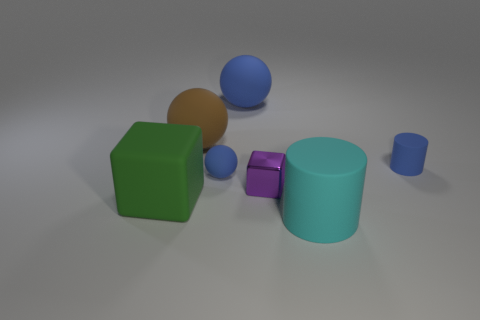Subtract all brown matte balls. How many balls are left? 2 Subtract all green blocks. How many blue balls are left? 2 Subtract all cylinders. How many objects are left? 5 Add 1 blue cylinders. How many objects exist? 8 Subtract all cyan cylinders. How many cylinders are left? 1 Subtract 2 cylinders. How many cylinders are left? 0 Subtract 0 yellow cubes. How many objects are left? 7 Subtract all purple balls. Subtract all yellow blocks. How many balls are left? 3 Subtract all green things. Subtract all shiny cubes. How many objects are left? 5 Add 4 large blue spheres. How many large blue spheres are left? 5 